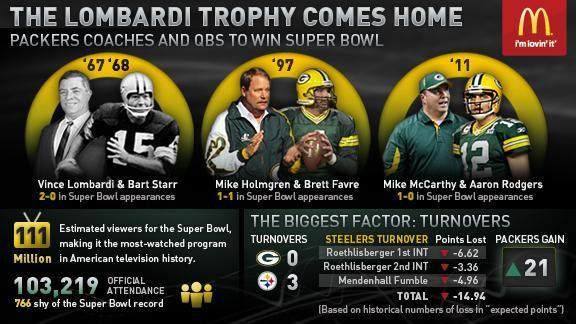Which quarter back player won the Lombardi trophy in 2011?
Answer the question with a short phrase. Aaron Rodgers Which coach won the Lombardi trophy in 1967 and 1968? Vince Lombardi 